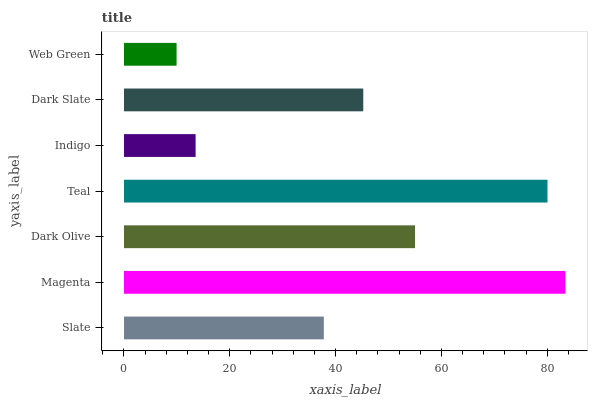Is Web Green the minimum?
Answer yes or no. Yes. Is Magenta the maximum?
Answer yes or no. Yes. Is Dark Olive the minimum?
Answer yes or no. No. Is Dark Olive the maximum?
Answer yes or no. No. Is Magenta greater than Dark Olive?
Answer yes or no. Yes. Is Dark Olive less than Magenta?
Answer yes or no. Yes. Is Dark Olive greater than Magenta?
Answer yes or no. No. Is Magenta less than Dark Olive?
Answer yes or no. No. Is Dark Slate the high median?
Answer yes or no. Yes. Is Dark Slate the low median?
Answer yes or no. Yes. Is Indigo the high median?
Answer yes or no. No. Is Teal the low median?
Answer yes or no. No. 